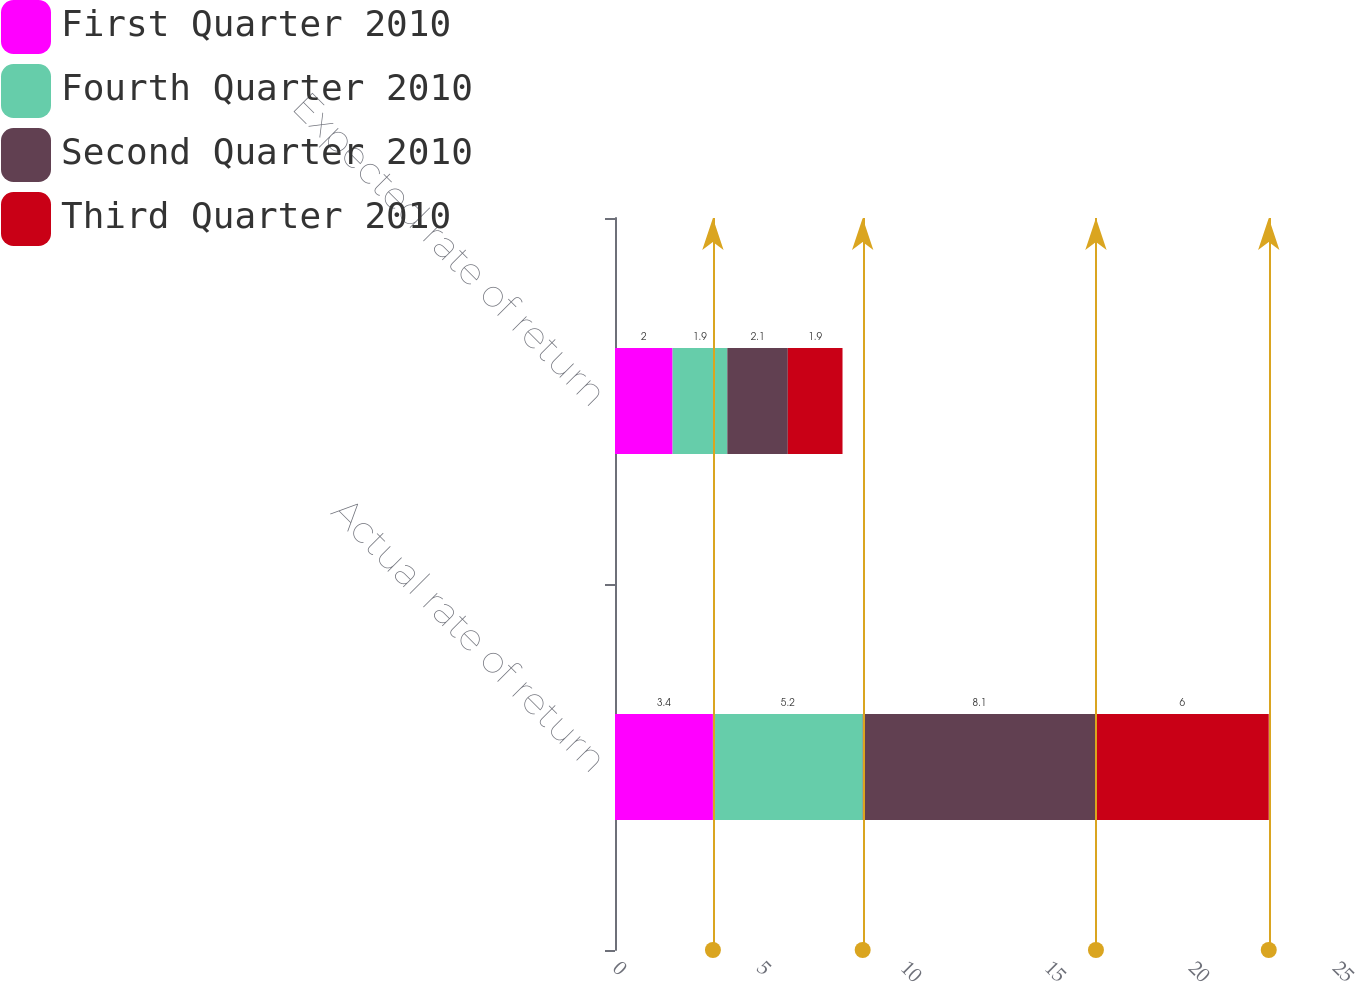Convert chart. <chart><loc_0><loc_0><loc_500><loc_500><stacked_bar_chart><ecel><fcel>Actual rate of return<fcel>Expected rate of return<nl><fcel>First Quarter 2010<fcel>3.4<fcel>2<nl><fcel>Fourth Quarter 2010<fcel>5.2<fcel>1.9<nl><fcel>Second Quarter 2010<fcel>8.1<fcel>2.1<nl><fcel>Third Quarter 2010<fcel>6<fcel>1.9<nl></chart> 